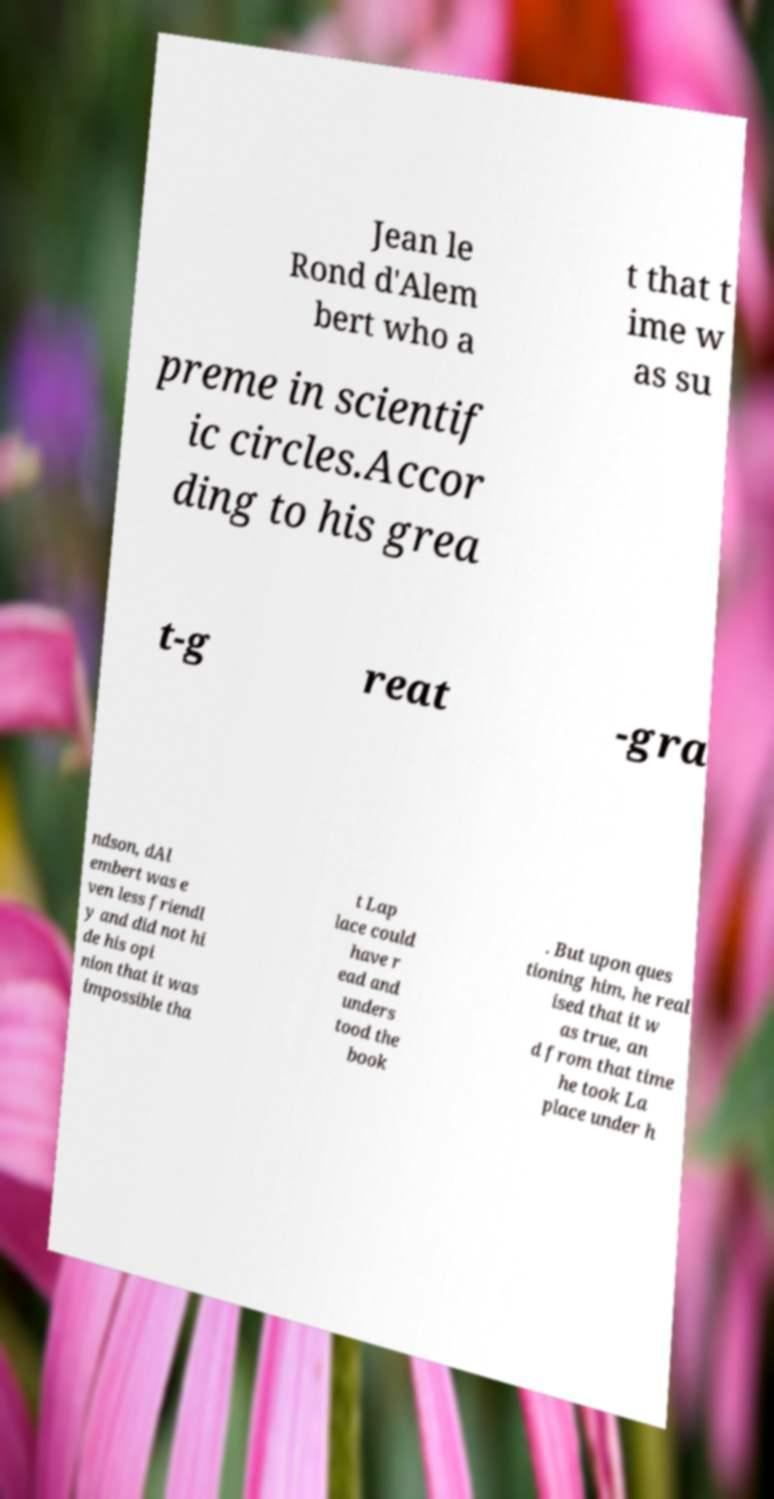I need the written content from this picture converted into text. Can you do that? Jean le Rond d'Alem bert who a t that t ime w as su preme in scientif ic circles.Accor ding to his grea t-g reat -gra ndson, dAl embert was e ven less friendl y and did not hi de his opi nion that it was impossible tha t Lap lace could have r ead and unders tood the book . But upon ques tioning him, he real ised that it w as true, an d from that time he took La place under h 